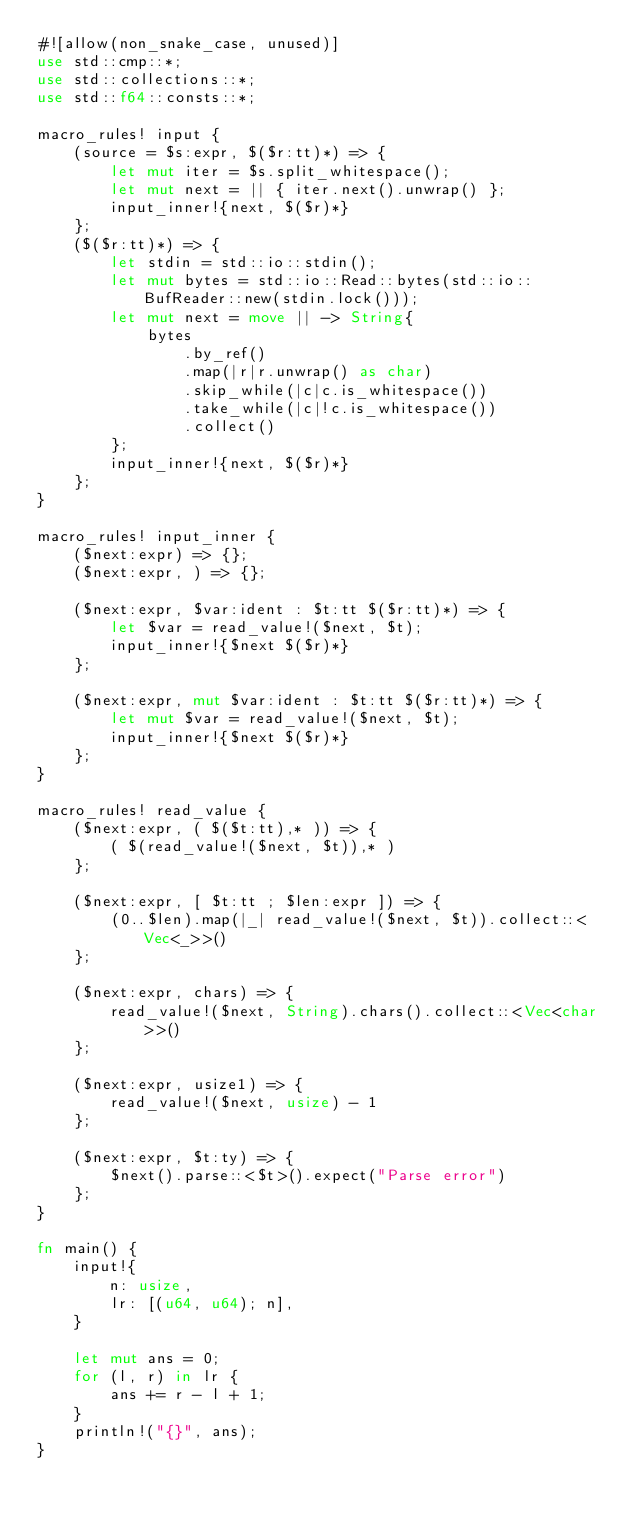Convert code to text. <code><loc_0><loc_0><loc_500><loc_500><_Rust_>#![allow(non_snake_case, unused)]
use std::cmp::*;
use std::collections::*;
use std::f64::consts::*;

macro_rules! input {
    (source = $s:expr, $($r:tt)*) => {
        let mut iter = $s.split_whitespace();
        let mut next = || { iter.next().unwrap() };
        input_inner!{next, $($r)*}
    };
    ($($r:tt)*) => {
        let stdin = std::io::stdin();
        let mut bytes = std::io::Read::bytes(std::io::BufReader::new(stdin.lock()));
        let mut next = move || -> String{
            bytes
                .by_ref()
                .map(|r|r.unwrap() as char)
                .skip_while(|c|c.is_whitespace())
                .take_while(|c|!c.is_whitespace())
                .collect()
        };
        input_inner!{next, $($r)*}
    };
}

macro_rules! input_inner {
    ($next:expr) => {};
    ($next:expr, ) => {};

    ($next:expr, $var:ident : $t:tt $($r:tt)*) => {
        let $var = read_value!($next, $t);
        input_inner!{$next $($r)*}
    };

    ($next:expr, mut $var:ident : $t:tt $($r:tt)*) => {
        let mut $var = read_value!($next, $t);
        input_inner!{$next $($r)*}
    };
}

macro_rules! read_value {
    ($next:expr, ( $($t:tt),* )) => {
        ( $(read_value!($next, $t)),* )
    };

    ($next:expr, [ $t:tt ; $len:expr ]) => {
        (0..$len).map(|_| read_value!($next, $t)).collect::<Vec<_>>()
    };

    ($next:expr, chars) => {
        read_value!($next, String).chars().collect::<Vec<char>>()
    };

    ($next:expr, usize1) => {
        read_value!($next, usize) - 1
    };

    ($next:expr, $t:ty) => {
        $next().parse::<$t>().expect("Parse error")
    };
}

fn main() {
    input!{
        n: usize,
        lr: [(u64, u64); n],
    }

    let mut ans = 0;
    for (l, r) in lr {
        ans += r - l + 1;
    }
    println!("{}", ans);
}
</code> 